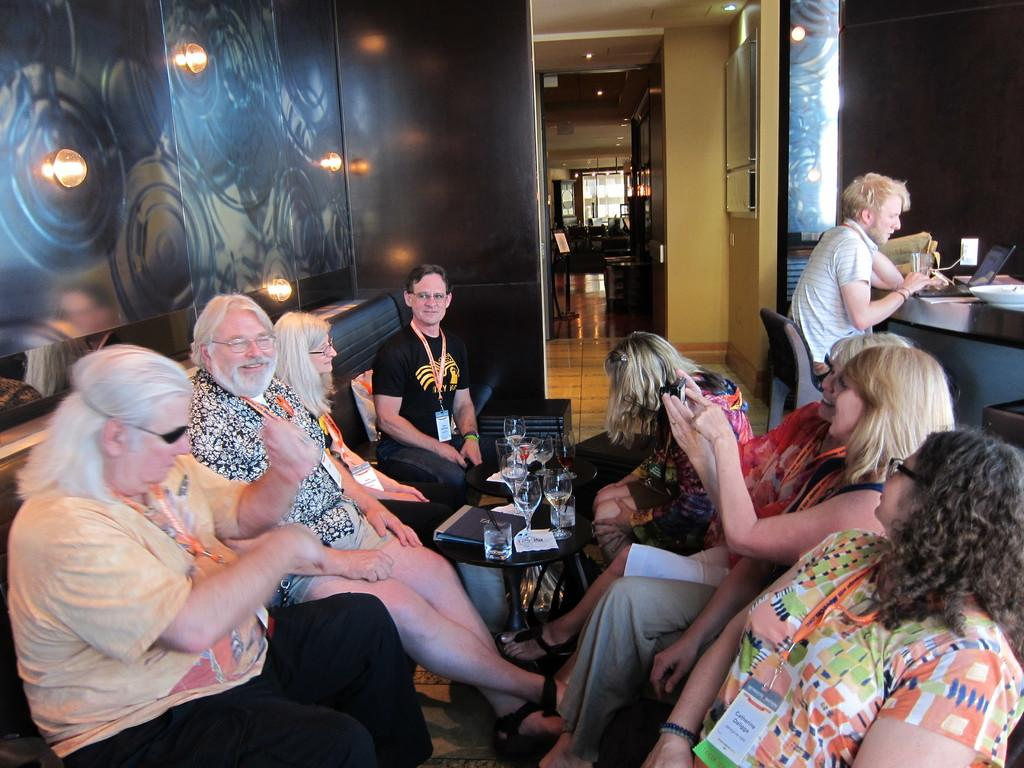What type of furniture is present in the image? There is a dining table, chairs, and a sofa in the image. What is the background of the image? There is a wall in the image. What is on the table in the image? There are glasses and papers on the table. Can you describe the table in the image? There is a table in the image. What type of shoe can be seen on the wall in the image? There is no shoe present on the wall in the image. How many cars are parked in front of the house in the image? There is no information about cars or a house in the image; it only features furniture and objects inside a room. 